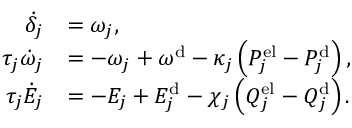<formula> <loc_0><loc_0><loc_500><loc_500>\begin{array} { r l } { \dot { \delta } _ { j } } & { = \omega _ { j } , } \\ { \tau _ { j } \dot { \omega } _ { j } } & { = - \omega _ { j } + \omega ^ { d } - \kappa _ { j } \left ( P _ { j } ^ { e l } - P _ { j } ^ { d } \right ) , } \\ { \tau _ { j } \dot { E } _ { j } } & { = - E _ { j } + E _ { j } ^ { d } - \chi _ { j } \left ( Q _ { j } ^ { e l } - Q _ { j } ^ { d } \right ) . } \end{array}</formula> 